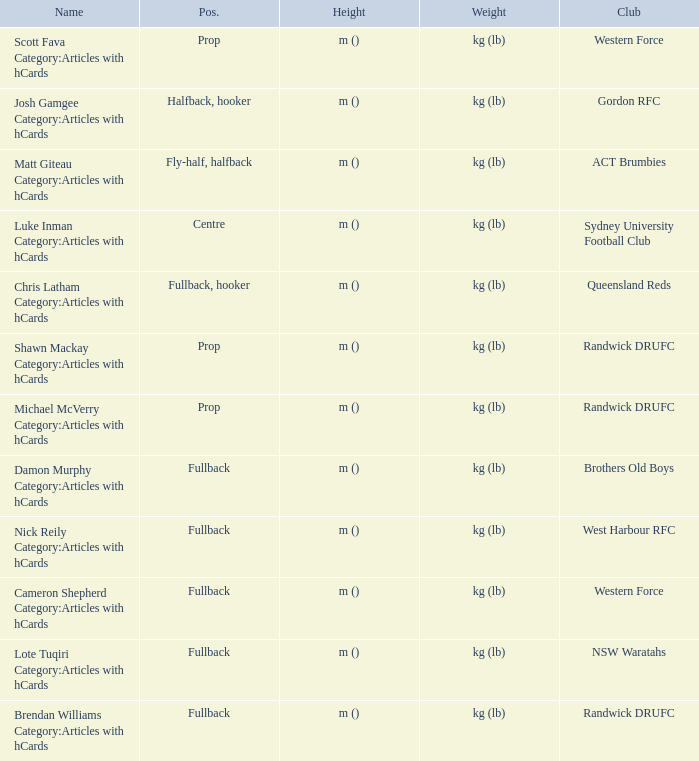What is the name when the position is centre? Luke Inman Category:Articles with hCards. 